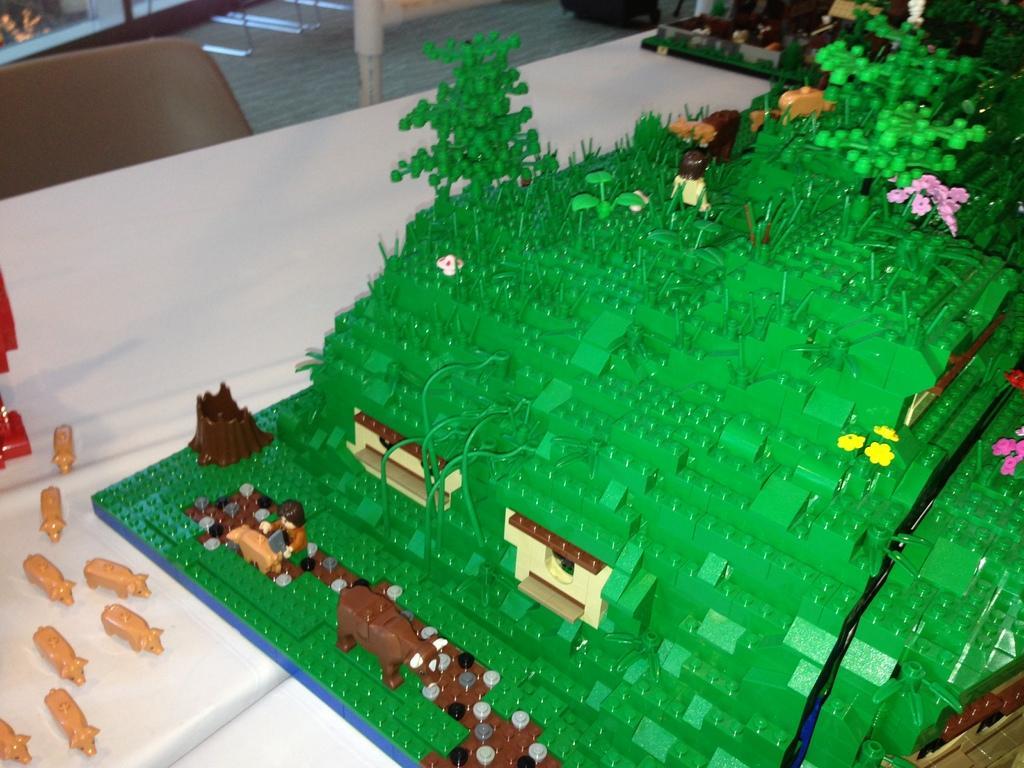How would you summarize this image in a sentence or two? On the white color table there is a model which is in green color. With trees, flower, human, windows, cattle, tree etc. To the left bottom there are some animal toys. And we can also see a chair. 